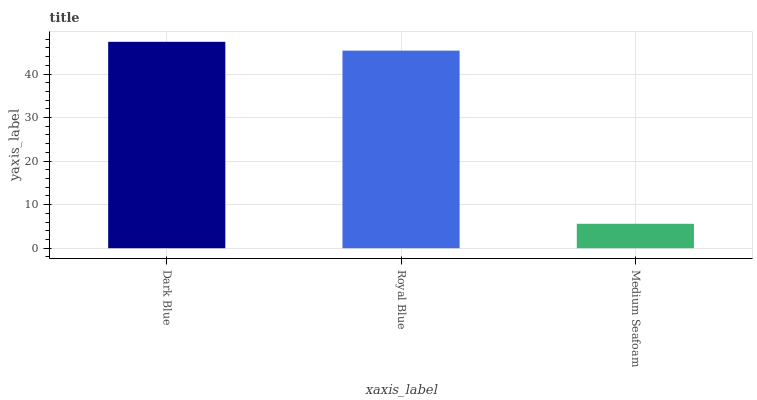Is Medium Seafoam the minimum?
Answer yes or no. Yes. Is Dark Blue the maximum?
Answer yes or no. Yes. Is Royal Blue the minimum?
Answer yes or no. No. Is Royal Blue the maximum?
Answer yes or no. No. Is Dark Blue greater than Royal Blue?
Answer yes or no. Yes. Is Royal Blue less than Dark Blue?
Answer yes or no. Yes. Is Royal Blue greater than Dark Blue?
Answer yes or no. No. Is Dark Blue less than Royal Blue?
Answer yes or no. No. Is Royal Blue the high median?
Answer yes or no. Yes. Is Royal Blue the low median?
Answer yes or no. Yes. Is Dark Blue the high median?
Answer yes or no. No. Is Dark Blue the low median?
Answer yes or no. No. 